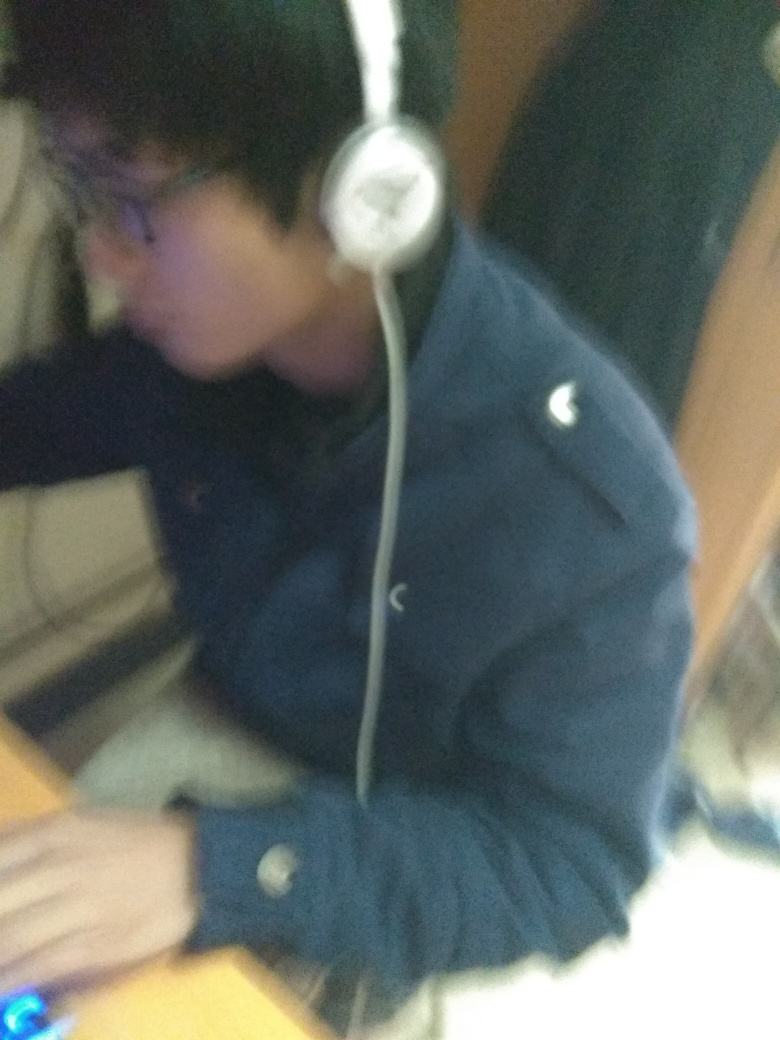What can you infer about the environment based on this image? The environment looks like an indoor setting, possibly a home or office, with a sense of casualness due to the unstructured background and soft lighting. 